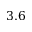<formula> <loc_0><loc_0><loc_500><loc_500>3 . 6</formula> 